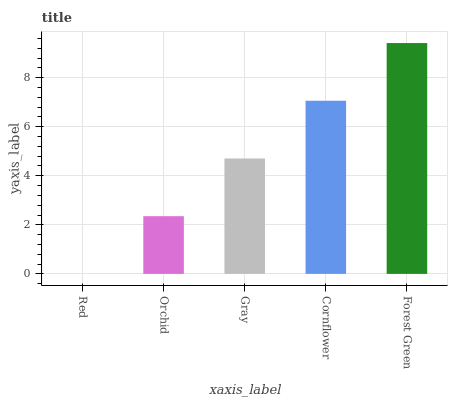Is Orchid the minimum?
Answer yes or no. No. Is Orchid the maximum?
Answer yes or no. No. Is Orchid greater than Red?
Answer yes or no. Yes. Is Red less than Orchid?
Answer yes or no. Yes. Is Red greater than Orchid?
Answer yes or no. No. Is Orchid less than Red?
Answer yes or no. No. Is Gray the high median?
Answer yes or no. Yes. Is Gray the low median?
Answer yes or no. Yes. Is Red the high median?
Answer yes or no. No. Is Red the low median?
Answer yes or no. No. 